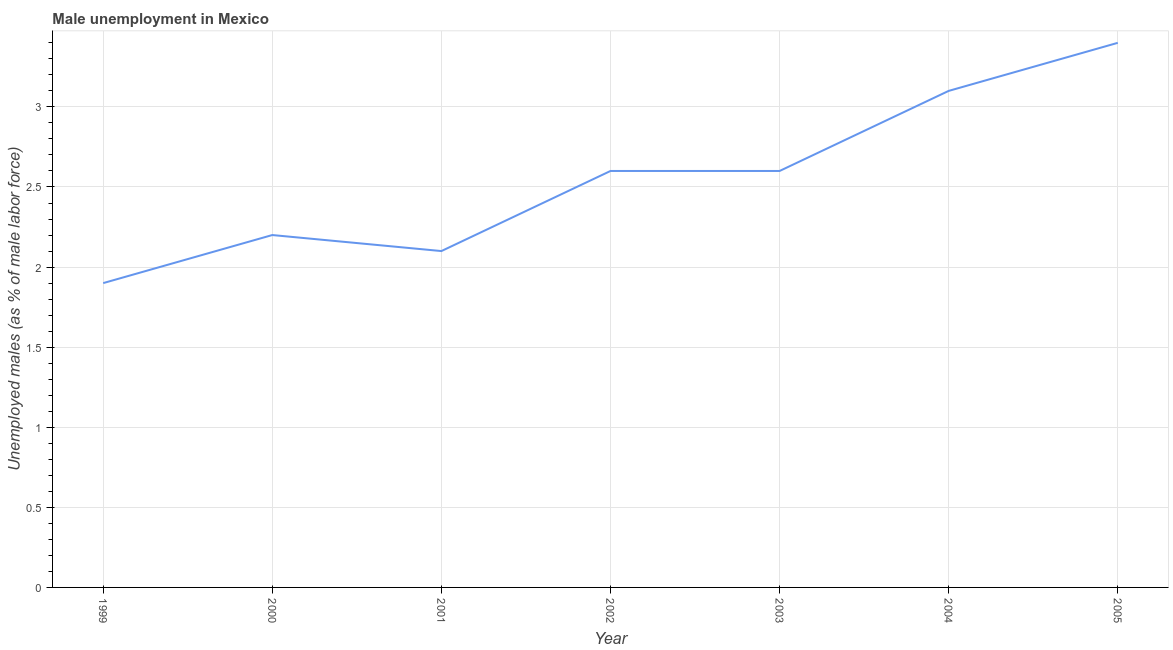What is the unemployed males population in 2000?
Offer a very short reply. 2.2. Across all years, what is the maximum unemployed males population?
Give a very brief answer. 3.4. Across all years, what is the minimum unemployed males population?
Offer a terse response. 1.9. In which year was the unemployed males population minimum?
Offer a terse response. 1999. What is the sum of the unemployed males population?
Keep it short and to the point. 17.9. What is the difference between the unemployed males population in 1999 and 2005?
Ensure brevity in your answer.  -1.5. What is the average unemployed males population per year?
Your answer should be very brief. 2.56. What is the median unemployed males population?
Offer a terse response. 2.6. In how many years, is the unemployed males population greater than 0.4 %?
Ensure brevity in your answer.  7. Do a majority of the years between 1999 and 2004 (inclusive) have unemployed males population greater than 2.9 %?
Your answer should be compact. No. What is the ratio of the unemployed males population in 2000 to that in 2002?
Ensure brevity in your answer.  0.85. Is the difference between the unemployed males population in 2000 and 2002 greater than the difference between any two years?
Your answer should be compact. No. What is the difference between the highest and the second highest unemployed males population?
Keep it short and to the point. 0.3. What is the difference between the highest and the lowest unemployed males population?
Your response must be concise. 1.5. In how many years, is the unemployed males population greater than the average unemployed males population taken over all years?
Offer a terse response. 4. Does the unemployed males population monotonically increase over the years?
Your answer should be very brief. No. How many lines are there?
Ensure brevity in your answer.  1. How many years are there in the graph?
Provide a short and direct response. 7. What is the difference between two consecutive major ticks on the Y-axis?
Provide a short and direct response. 0.5. Are the values on the major ticks of Y-axis written in scientific E-notation?
Make the answer very short. No. Does the graph contain any zero values?
Your answer should be very brief. No. Does the graph contain grids?
Make the answer very short. Yes. What is the title of the graph?
Ensure brevity in your answer.  Male unemployment in Mexico. What is the label or title of the X-axis?
Provide a succinct answer. Year. What is the label or title of the Y-axis?
Ensure brevity in your answer.  Unemployed males (as % of male labor force). What is the Unemployed males (as % of male labor force) in 1999?
Offer a very short reply. 1.9. What is the Unemployed males (as % of male labor force) of 2000?
Provide a succinct answer. 2.2. What is the Unemployed males (as % of male labor force) in 2001?
Your answer should be very brief. 2.1. What is the Unemployed males (as % of male labor force) of 2002?
Keep it short and to the point. 2.6. What is the Unemployed males (as % of male labor force) in 2003?
Offer a very short reply. 2.6. What is the Unemployed males (as % of male labor force) of 2004?
Provide a short and direct response. 3.1. What is the Unemployed males (as % of male labor force) of 2005?
Your response must be concise. 3.4. What is the difference between the Unemployed males (as % of male labor force) in 1999 and 2000?
Your response must be concise. -0.3. What is the difference between the Unemployed males (as % of male labor force) in 1999 and 2001?
Provide a succinct answer. -0.2. What is the difference between the Unemployed males (as % of male labor force) in 1999 and 2002?
Your answer should be very brief. -0.7. What is the difference between the Unemployed males (as % of male labor force) in 1999 and 2004?
Your answer should be compact. -1.2. What is the difference between the Unemployed males (as % of male labor force) in 2000 and 2001?
Your answer should be compact. 0.1. What is the difference between the Unemployed males (as % of male labor force) in 2001 and 2002?
Ensure brevity in your answer.  -0.5. What is the difference between the Unemployed males (as % of male labor force) in 2001 and 2005?
Offer a terse response. -1.3. What is the difference between the Unemployed males (as % of male labor force) in 2002 and 2005?
Give a very brief answer. -0.8. What is the difference between the Unemployed males (as % of male labor force) in 2003 and 2005?
Your answer should be compact. -0.8. What is the ratio of the Unemployed males (as % of male labor force) in 1999 to that in 2000?
Ensure brevity in your answer.  0.86. What is the ratio of the Unemployed males (as % of male labor force) in 1999 to that in 2001?
Offer a terse response. 0.91. What is the ratio of the Unemployed males (as % of male labor force) in 1999 to that in 2002?
Provide a short and direct response. 0.73. What is the ratio of the Unemployed males (as % of male labor force) in 1999 to that in 2003?
Offer a very short reply. 0.73. What is the ratio of the Unemployed males (as % of male labor force) in 1999 to that in 2004?
Keep it short and to the point. 0.61. What is the ratio of the Unemployed males (as % of male labor force) in 1999 to that in 2005?
Provide a short and direct response. 0.56. What is the ratio of the Unemployed males (as % of male labor force) in 2000 to that in 2001?
Provide a short and direct response. 1.05. What is the ratio of the Unemployed males (as % of male labor force) in 2000 to that in 2002?
Your answer should be very brief. 0.85. What is the ratio of the Unemployed males (as % of male labor force) in 2000 to that in 2003?
Offer a very short reply. 0.85. What is the ratio of the Unemployed males (as % of male labor force) in 2000 to that in 2004?
Your answer should be compact. 0.71. What is the ratio of the Unemployed males (as % of male labor force) in 2000 to that in 2005?
Offer a terse response. 0.65. What is the ratio of the Unemployed males (as % of male labor force) in 2001 to that in 2002?
Provide a short and direct response. 0.81. What is the ratio of the Unemployed males (as % of male labor force) in 2001 to that in 2003?
Your answer should be very brief. 0.81. What is the ratio of the Unemployed males (as % of male labor force) in 2001 to that in 2004?
Your response must be concise. 0.68. What is the ratio of the Unemployed males (as % of male labor force) in 2001 to that in 2005?
Your response must be concise. 0.62. What is the ratio of the Unemployed males (as % of male labor force) in 2002 to that in 2004?
Keep it short and to the point. 0.84. What is the ratio of the Unemployed males (as % of male labor force) in 2002 to that in 2005?
Offer a very short reply. 0.77. What is the ratio of the Unemployed males (as % of male labor force) in 2003 to that in 2004?
Your answer should be compact. 0.84. What is the ratio of the Unemployed males (as % of male labor force) in 2003 to that in 2005?
Your answer should be very brief. 0.77. What is the ratio of the Unemployed males (as % of male labor force) in 2004 to that in 2005?
Provide a succinct answer. 0.91. 